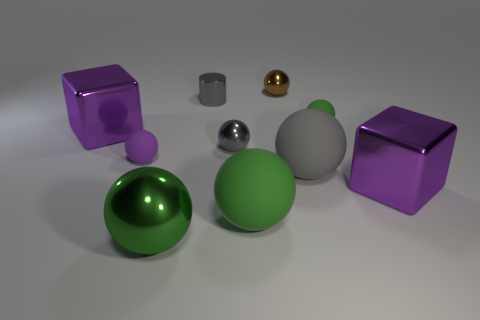How many green balls must be subtracted to get 1 green balls? 2 Subtract all cyan blocks. How many green balls are left? 3 Subtract 1 balls. How many balls are left? 6 Subtract all green balls. How many balls are left? 4 Subtract all metallic balls. How many balls are left? 4 Subtract all cyan spheres. Subtract all cyan blocks. How many spheres are left? 7 Subtract all cylinders. How many objects are left? 9 Add 4 brown shiny objects. How many brown shiny objects exist? 5 Subtract 0 red balls. How many objects are left? 10 Subtract all metal things. Subtract all big cyan shiny cylinders. How many objects are left? 4 